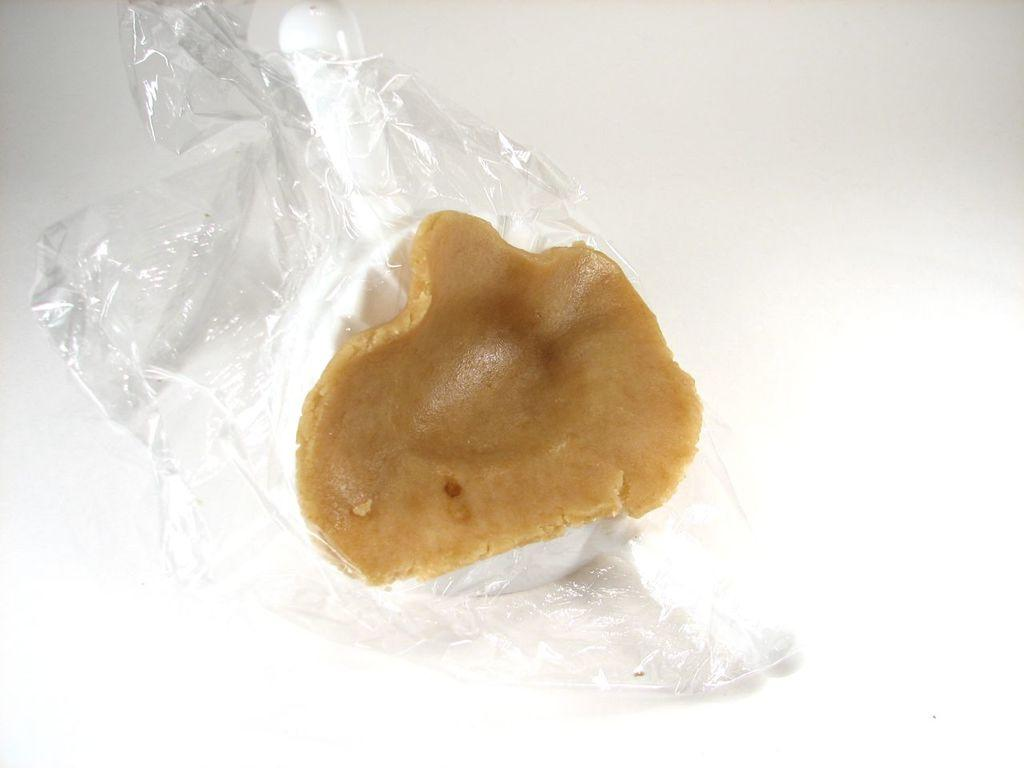What is the main subject of the image? There is an object that resembles a food item in the image. How is the food item presented in the image? The food item is placed on a plastic cover. What color is the background of the image? The background of the image is white. What hobbies does the food item enjoy in the image? The food item does not have hobbies, as it is an inanimate object. What is the limit of the shelf in the image? There is no shelf present in the image. 